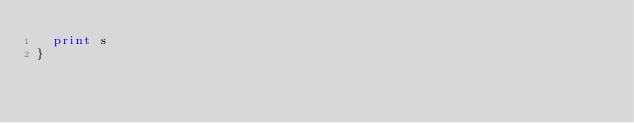<code> <loc_0><loc_0><loc_500><loc_500><_Awk_>  print s
}
</code> 